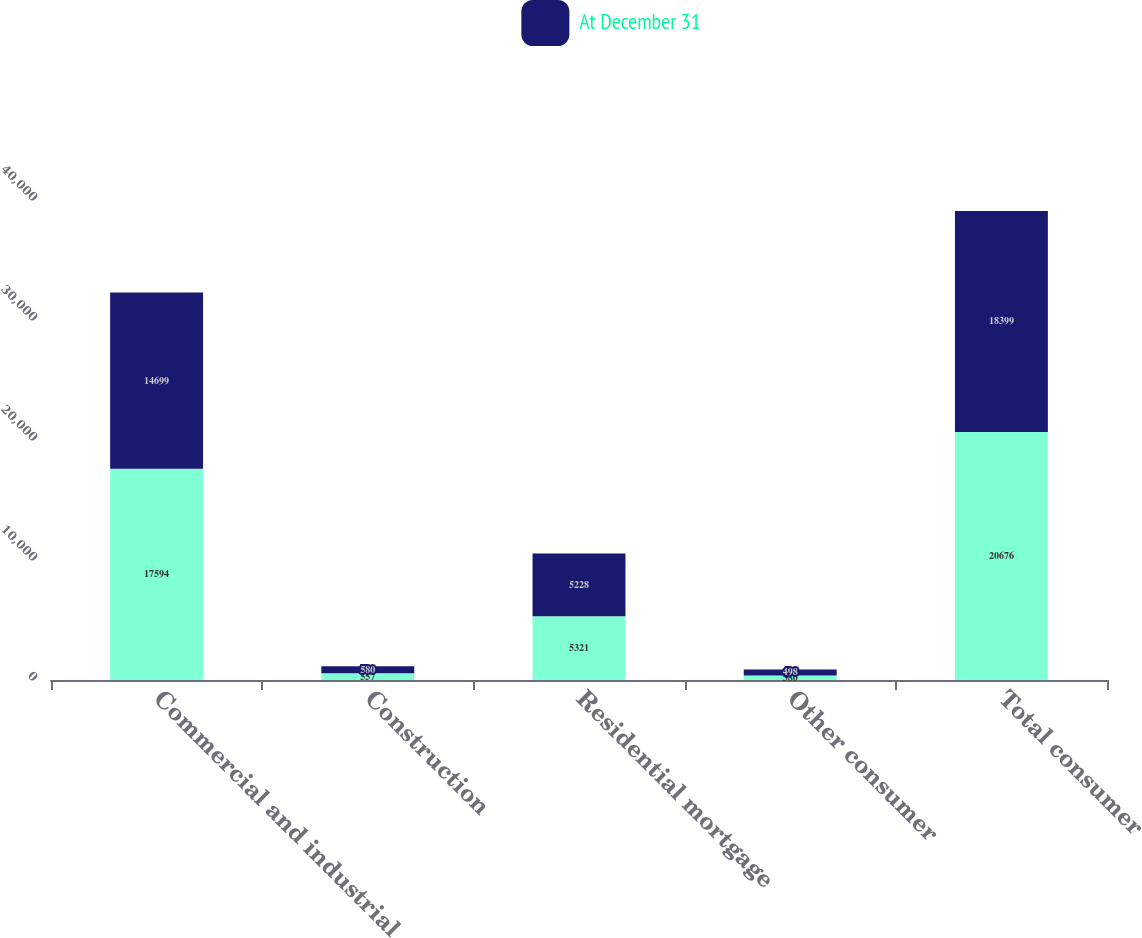<chart> <loc_0><loc_0><loc_500><loc_500><stacked_bar_chart><ecel><fcel>Commercial and industrial<fcel>Construction<fcel>Residential mortgage<fcel>Other consumer<fcel>Total consumer<nl><fcel>nan<fcel>17594<fcel>557<fcel>5321<fcel>380<fcel>20676<nl><fcel>At December 31<fcel>14699<fcel>580<fcel>5228<fcel>498<fcel>18399<nl></chart> 